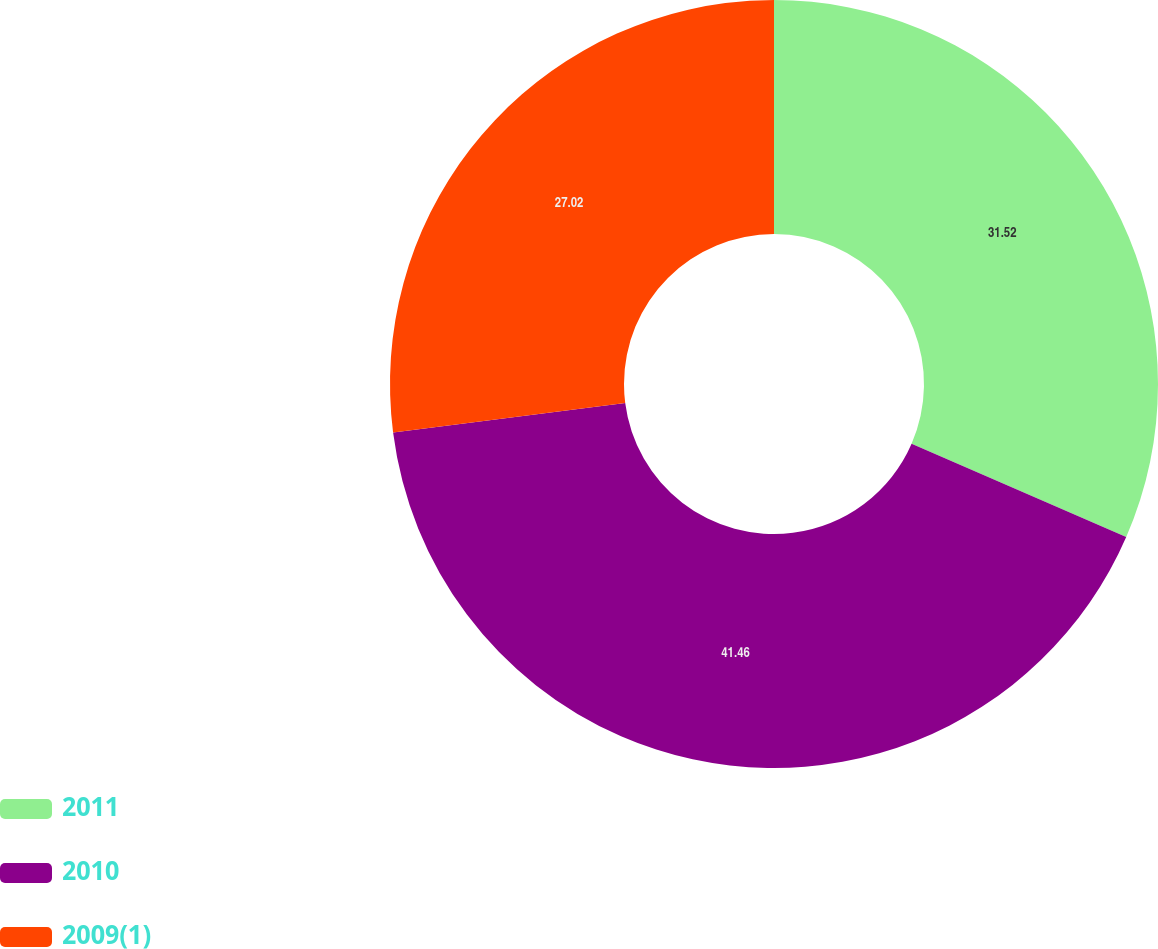Convert chart to OTSL. <chart><loc_0><loc_0><loc_500><loc_500><pie_chart><fcel>2011<fcel>2010<fcel>2009(1)<nl><fcel>31.52%<fcel>41.46%<fcel>27.02%<nl></chart> 